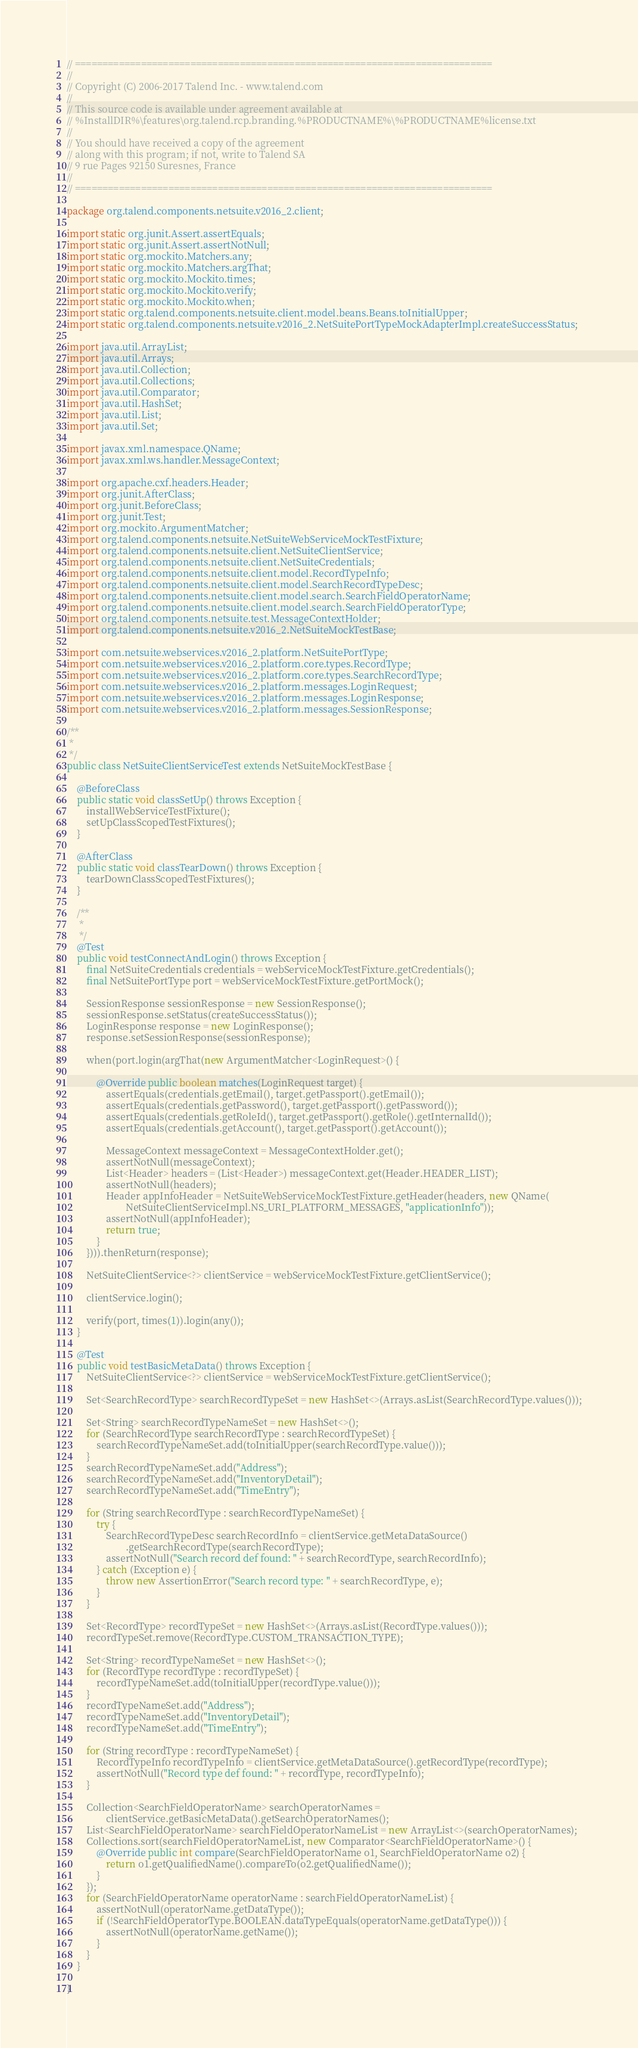Convert code to text. <code><loc_0><loc_0><loc_500><loc_500><_Java_>// ============================================================================
//
// Copyright (C) 2006-2017 Talend Inc. - www.talend.com
//
// This source code is available under agreement available at
// %InstallDIR%\features\org.talend.rcp.branding.%PRODUCTNAME%\%PRODUCTNAME%license.txt
//
// You should have received a copy of the agreement
// along with this program; if not, write to Talend SA
// 9 rue Pages 92150 Suresnes, France
//
// ============================================================================

package org.talend.components.netsuite.v2016_2.client;

import static org.junit.Assert.assertEquals;
import static org.junit.Assert.assertNotNull;
import static org.mockito.Matchers.any;
import static org.mockito.Matchers.argThat;
import static org.mockito.Mockito.times;
import static org.mockito.Mockito.verify;
import static org.mockito.Mockito.when;
import static org.talend.components.netsuite.client.model.beans.Beans.toInitialUpper;
import static org.talend.components.netsuite.v2016_2.NetSuitePortTypeMockAdapterImpl.createSuccessStatus;

import java.util.ArrayList;
import java.util.Arrays;
import java.util.Collection;
import java.util.Collections;
import java.util.Comparator;
import java.util.HashSet;
import java.util.List;
import java.util.Set;

import javax.xml.namespace.QName;
import javax.xml.ws.handler.MessageContext;

import org.apache.cxf.headers.Header;
import org.junit.AfterClass;
import org.junit.BeforeClass;
import org.junit.Test;
import org.mockito.ArgumentMatcher;
import org.talend.components.netsuite.NetSuiteWebServiceMockTestFixture;
import org.talend.components.netsuite.client.NetSuiteClientService;
import org.talend.components.netsuite.client.NetSuiteCredentials;
import org.talend.components.netsuite.client.model.RecordTypeInfo;
import org.talend.components.netsuite.client.model.SearchRecordTypeDesc;
import org.talend.components.netsuite.client.model.search.SearchFieldOperatorName;
import org.talend.components.netsuite.client.model.search.SearchFieldOperatorType;
import org.talend.components.netsuite.test.MessageContextHolder;
import org.talend.components.netsuite.v2016_2.NetSuiteMockTestBase;

import com.netsuite.webservices.v2016_2.platform.NetSuitePortType;
import com.netsuite.webservices.v2016_2.platform.core.types.RecordType;
import com.netsuite.webservices.v2016_2.platform.core.types.SearchRecordType;
import com.netsuite.webservices.v2016_2.platform.messages.LoginRequest;
import com.netsuite.webservices.v2016_2.platform.messages.LoginResponse;
import com.netsuite.webservices.v2016_2.platform.messages.SessionResponse;

/**
 *
 */
public class NetSuiteClientServiceTest extends NetSuiteMockTestBase {

    @BeforeClass
    public static void classSetUp() throws Exception {
        installWebServiceTestFixture();
        setUpClassScopedTestFixtures();
    }

    @AfterClass
    public static void classTearDown() throws Exception {
        tearDownClassScopedTestFixtures();
    }

    /**
     *
     */
    @Test
    public void testConnectAndLogin() throws Exception {
        final NetSuiteCredentials credentials = webServiceMockTestFixture.getCredentials();
        final NetSuitePortType port = webServiceMockTestFixture.getPortMock();

        SessionResponse sessionResponse = new SessionResponse();
        sessionResponse.setStatus(createSuccessStatus());
        LoginResponse response = new LoginResponse();
        response.setSessionResponse(sessionResponse);

        when(port.login(argThat(new ArgumentMatcher<LoginRequest>() {

            @Override public boolean matches(LoginRequest target) {
                assertEquals(credentials.getEmail(), target.getPassport().getEmail());
                assertEquals(credentials.getPassword(), target.getPassport().getPassword());
                assertEquals(credentials.getRoleId(), target.getPassport().getRole().getInternalId());
                assertEquals(credentials.getAccount(), target.getPassport().getAccount());

                MessageContext messageContext = MessageContextHolder.get();
                assertNotNull(messageContext);
                List<Header> headers = (List<Header>) messageContext.get(Header.HEADER_LIST);
                assertNotNull(headers);
                Header appInfoHeader = NetSuiteWebServiceMockTestFixture.getHeader(headers, new QName(
                        NetSuiteClientServiceImpl.NS_URI_PLATFORM_MESSAGES, "applicationInfo"));
                assertNotNull(appInfoHeader);
                return true;
            }
        }))).thenReturn(response);

        NetSuiteClientService<?> clientService = webServiceMockTestFixture.getClientService();

        clientService.login();

        verify(port, times(1)).login(any());
    }

    @Test
    public void testBasicMetaData() throws Exception {
        NetSuiteClientService<?> clientService = webServiceMockTestFixture.getClientService();

        Set<SearchRecordType> searchRecordTypeSet = new HashSet<>(Arrays.asList(SearchRecordType.values()));

        Set<String> searchRecordTypeNameSet = new HashSet<>();
        for (SearchRecordType searchRecordType : searchRecordTypeSet) {
            searchRecordTypeNameSet.add(toInitialUpper(searchRecordType.value()));
        }
        searchRecordTypeNameSet.add("Address");
        searchRecordTypeNameSet.add("InventoryDetail");
        searchRecordTypeNameSet.add("TimeEntry");

        for (String searchRecordType : searchRecordTypeNameSet) {
            try {
                SearchRecordTypeDesc searchRecordInfo = clientService.getMetaDataSource()
                        .getSearchRecordType(searchRecordType);
                assertNotNull("Search record def found: " + searchRecordType, searchRecordInfo);
            } catch (Exception e) {
                throw new AssertionError("Search record type: " + searchRecordType, e);
            }
        }

        Set<RecordType> recordTypeSet = new HashSet<>(Arrays.asList(RecordType.values()));
        recordTypeSet.remove(RecordType.CUSTOM_TRANSACTION_TYPE);

        Set<String> recordTypeNameSet = new HashSet<>();
        for (RecordType recordType : recordTypeSet) {
            recordTypeNameSet.add(toInitialUpper(recordType.value()));
        }
        recordTypeNameSet.add("Address");
        recordTypeNameSet.add("InventoryDetail");
        recordTypeNameSet.add("TimeEntry");

        for (String recordType : recordTypeNameSet) {
            RecordTypeInfo recordTypeInfo = clientService.getMetaDataSource().getRecordType(recordType);
            assertNotNull("Record type def found: " + recordType, recordTypeInfo);
        }

        Collection<SearchFieldOperatorName> searchOperatorNames =
                clientService.getBasicMetaData().getSearchOperatorNames();
        List<SearchFieldOperatorName> searchFieldOperatorNameList = new ArrayList<>(searchOperatorNames);
        Collections.sort(searchFieldOperatorNameList, new Comparator<SearchFieldOperatorName>() {
            @Override public int compare(SearchFieldOperatorName o1, SearchFieldOperatorName o2) {
                return o1.getQualifiedName().compareTo(o2.getQualifiedName());
            }
        });
        for (SearchFieldOperatorName operatorName : searchFieldOperatorNameList) {
            assertNotNull(operatorName.getDataType());
            if (!SearchFieldOperatorType.BOOLEAN.dataTypeEquals(operatorName.getDataType())) {
                assertNotNull(operatorName.getName());
            }
        }
    }

}</code> 